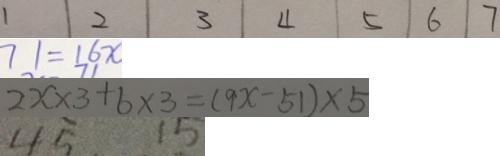Convert formula to latex. <formula><loc_0><loc_0><loc_500><loc_500>1 \vert 2 \vert 3 \vert 4 \vert 5 \vert 6 \vert 7 
 7 1 = 1 6 x 
 2 x \times 3 + b \times 3 = ( 9 x - 5 1 ) \times 5 
 4 5 1 5</formula> 